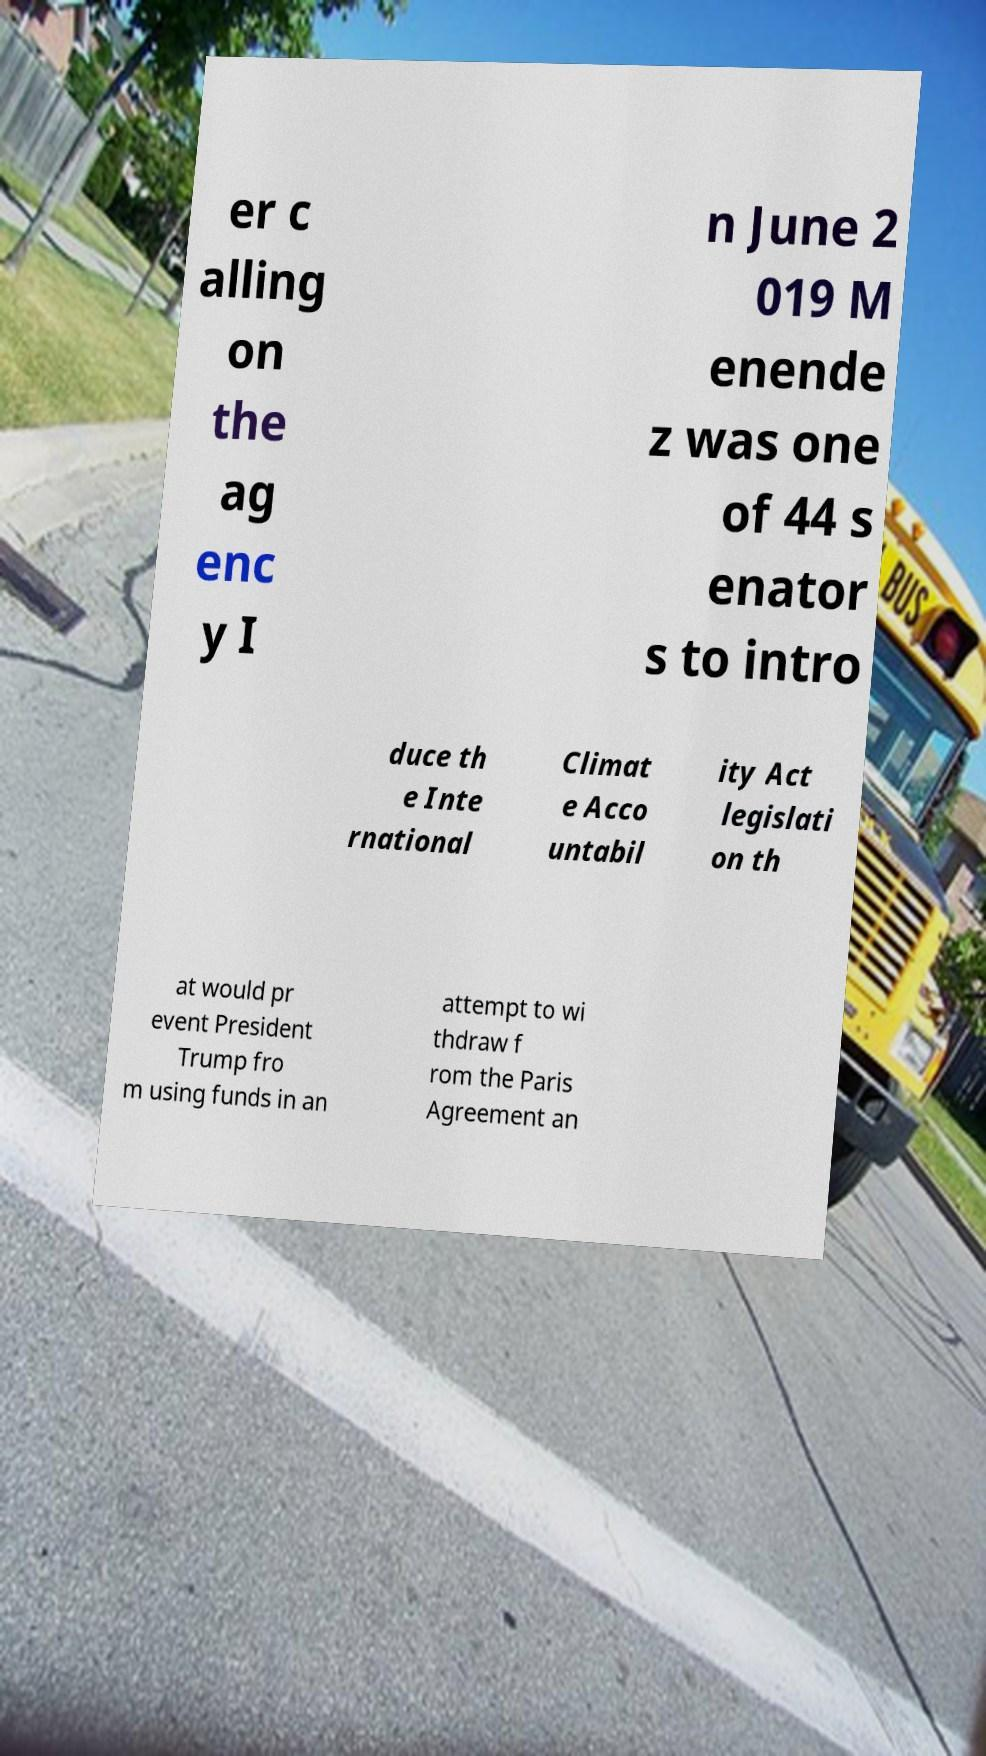Please identify and transcribe the text found in this image. er c alling on the ag enc y I n June 2 019 M enende z was one of 44 s enator s to intro duce th e Inte rnational Climat e Acco untabil ity Act legislati on th at would pr event President Trump fro m using funds in an attempt to wi thdraw f rom the Paris Agreement an 